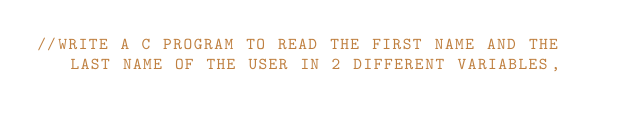<code> <loc_0><loc_0><loc_500><loc_500><_C_>//WRITE A C PROGRAM TO READ THE FIRST NAME AND THE LAST NAME OF THE USER IN 2 DIFFERENT VARIABLES,</code> 